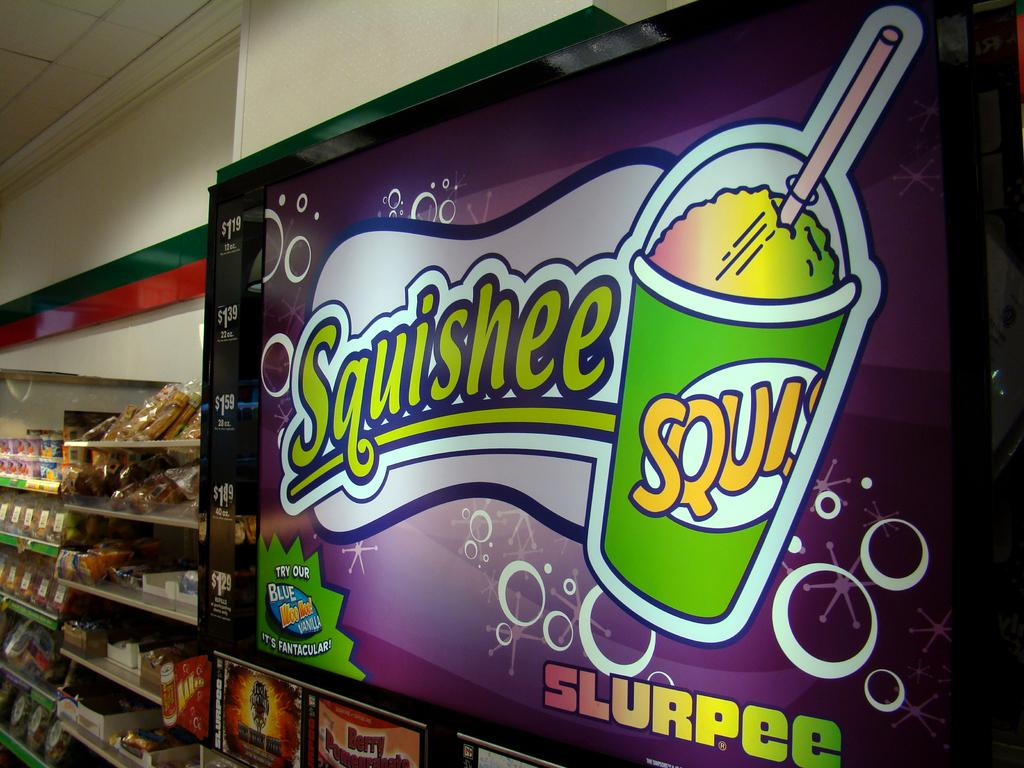<image>
Render a clear and concise summary of the photo. A lighted sign displays Squishee slurpees, next to a case of food. 